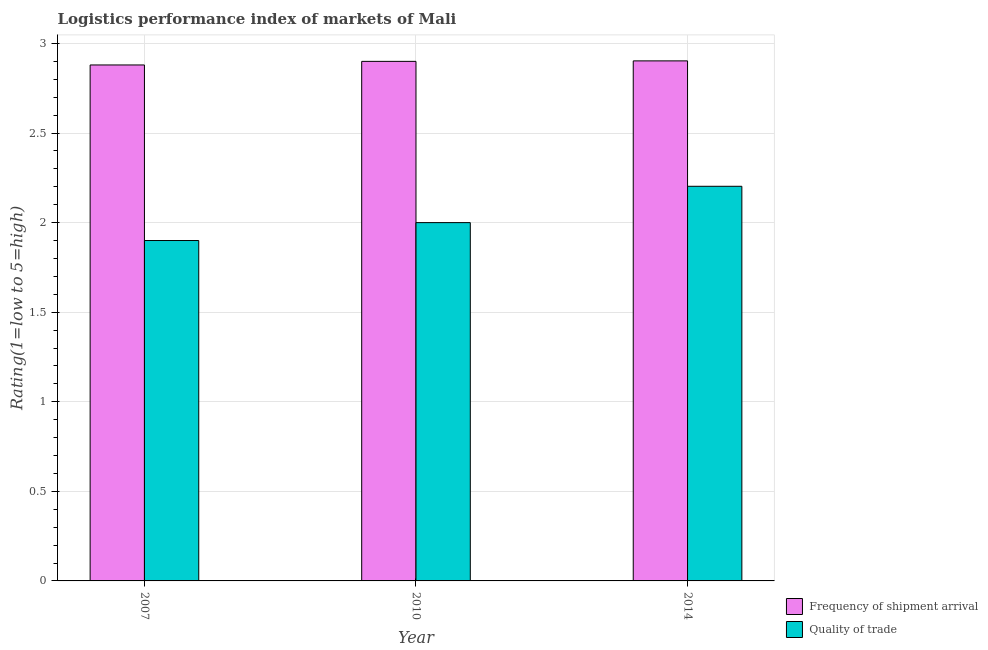How many different coloured bars are there?
Provide a succinct answer. 2. How many groups of bars are there?
Offer a very short reply. 3. How many bars are there on the 1st tick from the left?
Your response must be concise. 2. What is the lpi quality of trade in 2014?
Make the answer very short. 2.2. Across all years, what is the maximum lpi quality of trade?
Your response must be concise. 2.2. In which year was the lpi of frequency of shipment arrival maximum?
Keep it short and to the point. 2014. In which year was the lpi quality of trade minimum?
Your answer should be compact. 2007. What is the total lpi of frequency of shipment arrival in the graph?
Give a very brief answer. 8.68. What is the difference between the lpi quality of trade in 2007 and that in 2014?
Make the answer very short. -0.3. What is the difference between the lpi of frequency of shipment arrival in 2014 and the lpi quality of trade in 2007?
Keep it short and to the point. 0.02. What is the average lpi quality of trade per year?
Offer a very short reply. 2.03. What is the ratio of the lpi of frequency of shipment arrival in 2010 to that in 2014?
Your answer should be very brief. 1. Is the difference between the lpi of frequency of shipment arrival in 2007 and 2014 greater than the difference between the lpi quality of trade in 2007 and 2014?
Make the answer very short. No. What is the difference between the highest and the second highest lpi quality of trade?
Provide a succinct answer. 0.2. What is the difference between the highest and the lowest lpi quality of trade?
Your response must be concise. 0.3. In how many years, is the lpi quality of trade greater than the average lpi quality of trade taken over all years?
Keep it short and to the point. 1. Is the sum of the lpi quality of trade in 2007 and 2010 greater than the maximum lpi of frequency of shipment arrival across all years?
Ensure brevity in your answer.  Yes. What does the 2nd bar from the left in 2007 represents?
Your answer should be compact. Quality of trade. What does the 1st bar from the right in 2007 represents?
Offer a terse response. Quality of trade. How many bars are there?
Your answer should be compact. 6. Are all the bars in the graph horizontal?
Offer a terse response. No. Does the graph contain any zero values?
Ensure brevity in your answer.  No. How many legend labels are there?
Your answer should be very brief. 2. How are the legend labels stacked?
Provide a succinct answer. Vertical. What is the title of the graph?
Make the answer very short. Logistics performance index of markets of Mali. Does "Depositors" appear as one of the legend labels in the graph?
Make the answer very short. No. What is the label or title of the Y-axis?
Make the answer very short. Rating(1=low to 5=high). What is the Rating(1=low to 5=high) in Frequency of shipment arrival in 2007?
Give a very brief answer. 2.88. What is the Rating(1=low to 5=high) in Quality of trade in 2010?
Your answer should be very brief. 2. What is the Rating(1=low to 5=high) in Frequency of shipment arrival in 2014?
Make the answer very short. 2.9. What is the Rating(1=low to 5=high) of Quality of trade in 2014?
Ensure brevity in your answer.  2.2. Across all years, what is the maximum Rating(1=low to 5=high) of Frequency of shipment arrival?
Offer a very short reply. 2.9. Across all years, what is the maximum Rating(1=low to 5=high) in Quality of trade?
Provide a short and direct response. 2.2. Across all years, what is the minimum Rating(1=low to 5=high) in Frequency of shipment arrival?
Provide a succinct answer. 2.88. What is the total Rating(1=low to 5=high) in Frequency of shipment arrival in the graph?
Ensure brevity in your answer.  8.68. What is the total Rating(1=low to 5=high) of Quality of trade in the graph?
Your answer should be very brief. 6.1. What is the difference between the Rating(1=low to 5=high) in Frequency of shipment arrival in 2007 and that in 2010?
Give a very brief answer. -0.02. What is the difference between the Rating(1=low to 5=high) of Quality of trade in 2007 and that in 2010?
Ensure brevity in your answer.  -0.1. What is the difference between the Rating(1=low to 5=high) of Frequency of shipment arrival in 2007 and that in 2014?
Your answer should be compact. -0.02. What is the difference between the Rating(1=low to 5=high) of Quality of trade in 2007 and that in 2014?
Ensure brevity in your answer.  -0.3. What is the difference between the Rating(1=low to 5=high) of Frequency of shipment arrival in 2010 and that in 2014?
Your answer should be compact. -0. What is the difference between the Rating(1=low to 5=high) in Quality of trade in 2010 and that in 2014?
Your answer should be very brief. -0.2. What is the difference between the Rating(1=low to 5=high) of Frequency of shipment arrival in 2007 and the Rating(1=low to 5=high) of Quality of trade in 2014?
Your response must be concise. 0.68. What is the difference between the Rating(1=low to 5=high) in Frequency of shipment arrival in 2010 and the Rating(1=low to 5=high) in Quality of trade in 2014?
Offer a very short reply. 0.7. What is the average Rating(1=low to 5=high) in Frequency of shipment arrival per year?
Make the answer very short. 2.89. What is the average Rating(1=low to 5=high) of Quality of trade per year?
Make the answer very short. 2.03. In the year 2007, what is the difference between the Rating(1=low to 5=high) in Frequency of shipment arrival and Rating(1=low to 5=high) in Quality of trade?
Your answer should be very brief. 0.98. What is the ratio of the Rating(1=low to 5=high) of Frequency of shipment arrival in 2007 to that in 2014?
Your answer should be compact. 0.99. What is the ratio of the Rating(1=low to 5=high) of Quality of trade in 2007 to that in 2014?
Ensure brevity in your answer.  0.86. What is the ratio of the Rating(1=low to 5=high) of Quality of trade in 2010 to that in 2014?
Offer a very short reply. 0.91. What is the difference between the highest and the second highest Rating(1=low to 5=high) in Frequency of shipment arrival?
Your answer should be very brief. 0. What is the difference between the highest and the second highest Rating(1=low to 5=high) of Quality of trade?
Your answer should be compact. 0.2. What is the difference between the highest and the lowest Rating(1=low to 5=high) in Frequency of shipment arrival?
Provide a short and direct response. 0.02. What is the difference between the highest and the lowest Rating(1=low to 5=high) of Quality of trade?
Offer a terse response. 0.3. 